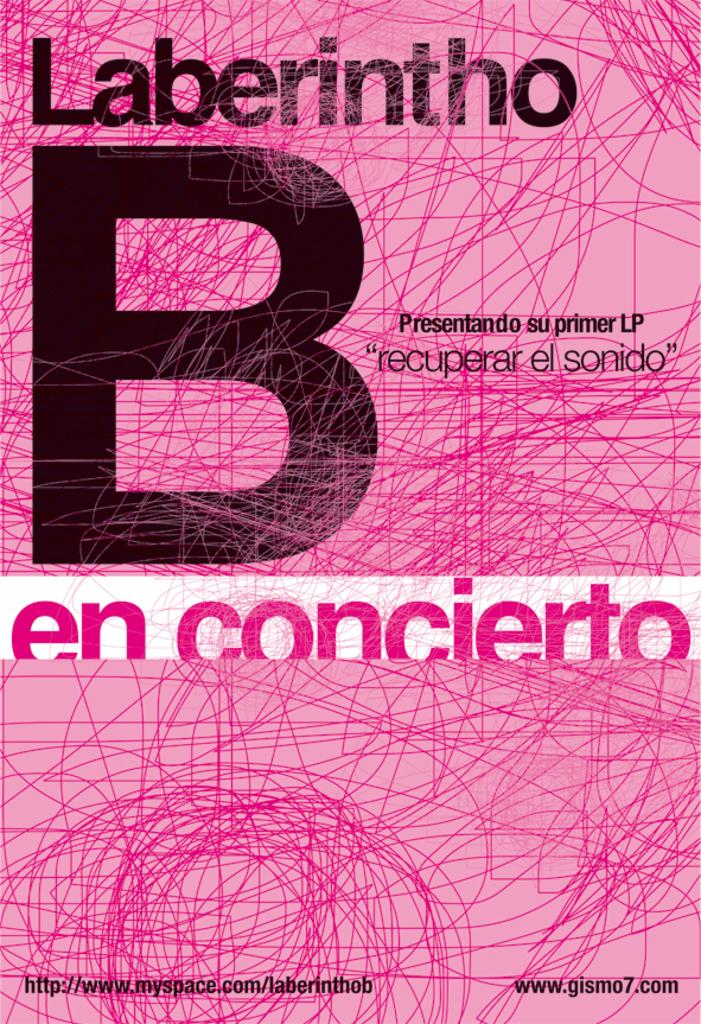<image>
Render a clear and concise summary of the photo. A poster announcing the first LP of Laberintho with a pink background. 